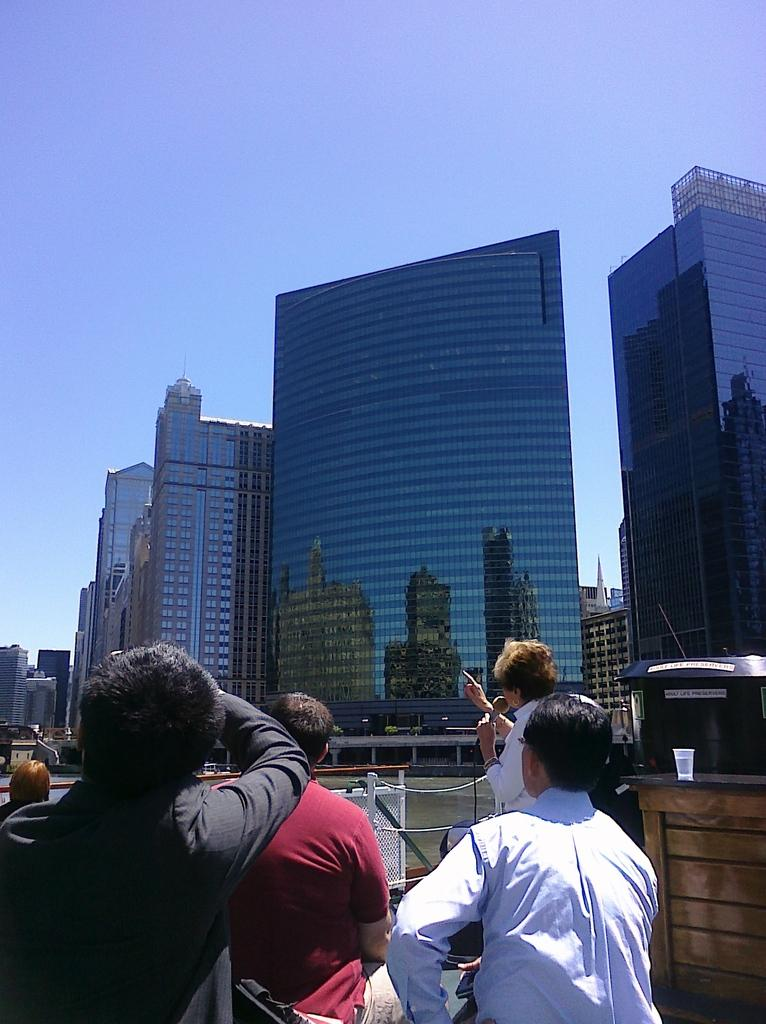What is happening in the bottom of the image? There are people standing in the bottom of the image. What can be seen in the distance in the image? There are buildings in the background of the image. How many flies can be seen on the dirt in the image? There is no dirt or flies present in the image. 